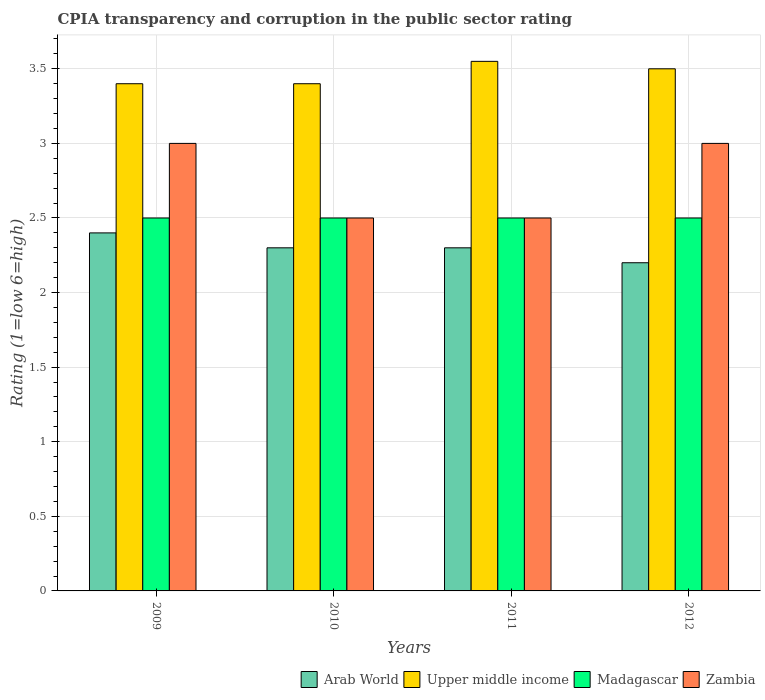How many different coloured bars are there?
Offer a very short reply. 4. How many bars are there on the 4th tick from the left?
Provide a succinct answer. 4. How many bars are there on the 2nd tick from the right?
Provide a short and direct response. 4. In how many cases, is the number of bars for a given year not equal to the number of legend labels?
Provide a succinct answer. 0. What is the CPIA rating in Arab World in 2011?
Provide a short and direct response. 2.3. In which year was the CPIA rating in Arab World minimum?
Give a very brief answer. 2012. What is the total CPIA rating in Upper middle income in the graph?
Your response must be concise. 13.85. What is the difference between the CPIA rating in Upper middle income in 2009 and that in 2011?
Ensure brevity in your answer.  -0.15. What is the difference between the CPIA rating in Arab World in 2011 and the CPIA rating in Madagascar in 2009?
Make the answer very short. -0.2. In the year 2009, what is the difference between the CPIA rating in Madagascar and CPIA rating in Upper middle income?
Give a very brief answer. -0.9. In how many years, is the CPIA rating in Madagascar greater than 2?
Make the answer very short. 4. What is the ratio of the CPIA rating in Arab World in 2010 to that in 2012?
Your response must be concise. 1.05. Is the CPIA rating in Upper middle income in 2009 less than that in 2012?
Your response must be concise. Yes. Is the difference between the CPIA rating in Madagascar in 2009 and 2012 greater than the difference between the CPIA rating in Upper middle income in 2009 and 2012?
Offer a very short reply. Yes. What is the difference between the highest and the second highest CPIA rating in Madagascar?
Give a very brief answer. 0. What is the difference between the highest and the lowest CPIA rating in Zambia?
Provide a succinct answer. 0.5. In how many years, is the CPIA rating in Madagascar greater than the average CPIA rating in Madagascar taken over all years?
Offer a very short reply. 0. Is it the case that in every year, the sum of the CPIA rating in Upper middle income and CPIA rating in Zambia is greater than the sum of CPIA rating in Arab World and CPIA rating in Madagascar?
Offer a terse response. No. What does the 3rd bar from the left in 2009 represents?
Offer a very short reply. Madagascar. What does the 2nd bar from the right in 2011 represents?
Your answer should be compact. Madagascar. How many bars are there?
Provide a succinct answer. 16. Are the values on the major ticks of Y-axis written in scientific E-notation?
Provide a short and direct response. No. Does the graph contain any zero values?
Make the answer very short. No. Does the graph contain grids?
Make the answer very short. Yes. How many legend labels are there?
Offer a terse response. 4. How are the legend labels stacked?
Make the answer very short. Horizontal. What is the title of the graph?
Provide a succinct answer. CPIA transparency and corruption in the public sector rating. What is the label or title of the X-axis?
Make the answer very short. Years. What is the Rating (1=low 6=high) in Arab World in 2009?
Your response must be concise. 2.4. What is the Rating (1=low 6=high) in Upper middle income in 2009?
Your answer should be very brief. 3.4. What is the Rating (1=low 6=high) of Zambia in 2009?
Provide a succinct answer. 3. What is the Rating (1=low 6=high) of Upper middle income in 2010?
Provide a short and direct response. 3.4. What is the Rating (1=low 6=high) in Madagascar in 2010?
Your answer should be compact. 2.5. What is the Rating (1=low 6=high) of Arab World in 2011?
Ensure brevity in your answer.  2.3. What is the Rating (1=low 6=high) in Upper middle income in 2011?
Offer a very short reply. 3.55. What is the Rating (1=low 6=high) in Arab World in 2012?
Ensure brevity in your answer.  2.2. What is the Rating (1=low 6=high) in Upper middle income in 2012?
Make the answer very short. 3.5. What is the Rating (1=low 6=high) in Madagascar in 2012?
Provide a short and direct response. 2.5. Across all years, what is the maximum Rating (1=low 6=high) in Upper middle income?
Offer a very short reply. 3.55. Across all years, what is the maximum Rating (1=low 6=high) of Zambia?
Your answer should be compact. 3. Across all years, what is the minimum Rating (1=low 6=high) in Upper middle income?
Offer a terse response. 3.4. Across all years, what is the minimum Rating (1=low 6=high) of Zambia?
Ensure brevity in your answer.  2.5. What is the total Rating (1=low 6=high) in Upper middle income in the graph?
Ensure brevity in your answer.  13.85. What is the total Rating (1=low 6=high) of Zambia in the graph?
Keep it short and to the point. 11. What is the difference between the Rating (1=low 6=high) of Arab World in 2009 and that in 2010?
Keep it short and to the point. 0.1. What is the difference between the Rating (1=low 6=high) in Madagascar in 2009 and that in 2010?
Your answer should be very brief. 0. What is the difference between the Rating (1=low 6=high) of Zambia in 2009 and that in 2010?
Provide a short and direct response. 0.5. What is the difference between the Rating (1=low 6=high) of Arab World in 2009 and that in 2011?
Provide a short and direct response. 0.1. What is the difference between the Rating (1=low 6=high) in Zambia in 2009 and that in 2011?
Offer a very short reply. 0.5. What is the difference between the Rating (1=low 6=high) in Madagascar in 2010 and that in 2011?
Provide a succinct answer. 0. What is the difference between the Rating (1=low 6=high) in Arab World in 2010 and that in 2012?
Offer a terse response. 0.1. What is the difference between the Rating (1=low 6=high) in Upper middle income in 2010 and that in 2012?
Provide a succinct answer. -0.1. What is the difference between the Rating (1=low 6=high) of Madagascar in 2010 and that in 2012?
Provide a short and direct response. 0. What is the difference between the Rating (1=low 6=high) in Upper middle income in 2011 and that in 2012?
Provide a short and direct response. 0.05. What is the difference between the Rating (1=low 6=high) in Arab World in 2009 and the Rating (1=low 6=high) in Madagascar in 2010?
Your answer should be very brief. -0.1. What is the difference between the Rating (1=low 6=high) in Arab World in 2009 and the Rating (1=low 6=high) in Zambia in 2010?
Provide a short and direct response. -0.1. What is the difference between the Rating (1=low 6=high) of Madagascar in 2009 and the Rating (1=low 6=high) of Zambia in 2010?
Provide a succinct answer. 0. What is the difference between the Rating (1=low 6=high) of Arab World in 2009 and the Rating (1=low 6=high) of Upper middle income in 2011?
Offer a terse response. -1.15. What is the difference between the Rating (1=low 6=high) of Madagascar in 2009 and the Rating (1=low 6=high) of Zambia in 2011?
Your response must be concise. 0. What is the difference between the Rating (1=low 6=high) in Arab World in 2009 and the Rating (1=low 6=high) in Upper middle income in 2012?
Your answer should be compact. -1.1. What is the difference between the Rating (1=low 6=high) of Arab World in 2009 and the Rating (1=low 6=high) of Madagascar in 2012?
Provide a succinct answer. -0.1. What is the difference between the Rating (1=low 6=high) of Upper middle income in 2009 and the Rating (1=low 6=high) of Zambia in 2012?
Keep it short and to the point. 0.4. What is the difference between the Rating (1=low 6=high) in Arab World in 2010 and the Rating (1=low 6=high) in Upper middle income in 2011?
Ensure brevity in your answer.  -1.25. What is the difference between the Rating (1=low 6=high) of Arab World in 2010 and the Rating (1=low 6=high) of Madagascar in 2011?
Ensure brevity in your answer.  -0.2. What is the difference between the Rating (1=low 6=high) in Upper middle income in 2010 and the Rating (1=low 6=high) in Madagascar in 2011?
Provide a succinct answer. 0.9. What is the difference between the Rating (1=low 6=high) in Arab World in 2010 and the Rating (1=low 6=high) in Zambia in 2012?
Provide a succinct answer. -0.7. What is the difference between the Rating (1=low 6=high) in Upper middle income in 2010 and the Rating (1=low 6=high) in Madagascar in 2012?
Your response must be concise. 0.9. What is the difference between the Rating (1=low 6=high) of Arab World in 2011 and the Rating (1=low 6=high) of Upper middle income in 2012?
Ensure brevity in your answer.  -1.2. What is the difference between the Rating (1=low 6=high) of Arab World in 2011 and the Rating (1=low 6=high) of Zambia in 2012?
Your answer should be compact. -0.7. What is the difference between the Rating (1=low 6=high) in Upper middle income in 2011 and the Rating (1=low 6=high) in Zambia in 2012?
Provide a short and direct response. 0.55. What is the difference between the Rating (1=low 6=high) of Madagascar in 2011 and the Rating (1=low 6=high) of Zambia in 2012?
Ensure brevity in your answer.  -0.5. What is the average Rating (1=low 6=high) of Arab World per year?
Provide a short and direct response. 2.3. What is the average Rating (1=low 6=high) in Upper middle income per year?
Provide a short and direct response. 3.46. What is the average Rating (1=low 6=high) of Zambia per year?
Provide a short and direct response. 2.75. In the year 2009, what is the difference between the Rating (1=low 6=high) of Arab World and Rating (1=low 6=high) of Upper middle income?
Offer a very short reply. -1. In the year 2009, what is the difference between the Rating (1=low 6=high) of Arab World and Rating (1=low 6=high) of Madagascar?
Offer a terse response. -0.1. In the year 2009, what is the difference between the Rating (1=low 6=high) of Madagascar and Rating (1=low 6=high) of Zambia?
Provide a short and direct response. -0.5. In the year 2010, what is the difference between the Rating (1=low 6=high) in Arab World and Rating (1=low 6=high) in Upper middle income?
Offer a terse response. -1.1. In the year 2010, what is the difference between the Rating (1=low 6=high) of Arab World and Rating (1=low 6=high) of Madagascar?
Give a very brief answer. -0.2. In the year 2010, what is the difference between the Rating (1=low 6=high) of Arab World and Rating (1=low 6=high) of Zambia?
Keep it short and to the point. -0.2. In the year 2010, what is the difference between the Rating (1=low 6=high) of Upper middle income and Rating (1=low 6=high) of Madagascar?
Your answer should be very brief. 0.9. In the year 2010, what is the difference between the Rating (1=low 6=high) of Madagascar and Rating (1=low 6=high) of Zambia?
Your answer should be very brief. 0. In the year 2011, what is the difference between the Rating (1=low 6=high) in Arab World and Rating (1=low 6=high) in Upper middle income?
Make the answer very short. -1.25. In the year 2011, what is the difference between the Rating (1=low 6=high) in Arab World and Rating (1=low 6=high) in Madagascar?
Make the answer very short. -0.2. In the year 2011, what is the difference between the Rating (1=low 6=high) of Arab World and Rating (1=low 6=high) of Zambia?
Offer a terse response. -0.2. In the year 2011, what is the difference between the Rating (1=low 6=high) in Upper middle income and Rating (1=low 6=high) in Madagascar?
Your response must be concise. 1.05. In the year 2011, what is the difference between the Rating (1=low 6=high) in Upper middle income and Rating (1=low 6=high) in Zambia?
Offer a terse response. 1.05. In the year 2011, what is the difference between the Rating (1=low 6=high) in Madagascar and Rating (1=low 6=high) in Zambia?
Offer a terse response. 0. In the year 2012, what is the difference between the Rating (1=low 6=high) of Arab World and Rating (1=low 6=high) of Madagascar?
Keep it short and to the point. -0.3. In the year 2012, what is the difference between the Rating (1=low 6=high) in Upper middle income and Rating (1=low 6=high) in Madagascar?
Offer a terse response. 1. In the year 2012, what is the difference between the Rating (1=low 6=high) in Madagascar and Rating (1=low 6=high) in Zambia?
Your answer should be compact. -0.5. What is the ratio of the Rating (1=low 6=high) of Arab World in 2009 to that in 2010?
Provide a succinct answer. 1.04. What is the ratio of the Rating (1=low 6=high) in Madagascar in 2009 to that in 2010?
Keep it short and to the point. 1. What is the ratio of the Rating (1=low 6=high) in Arab World in 2009 to that in 2011?
Give a very brief answer. 1.04. What is the ratio of the Rating (1=low 6=high) in Upper middle income in 2009 to that in 2011?
Provide a short and direct response. 0.96. What is the ratio of the Rating (1=low 6=high) in Madagascar in 2009 to that in 2011?
Your answer should be very brief. 1. What is the ratio of the Rating (1=low 6=high) of Arab World in 2009 to that in 2012?
Keep it short and to the point. 1.09. What is the ratio of the Rating (1=low 6=high) in Upper middle income in 2009 to that in 2012?
Offer a terse response. 0.97. What is the ratio of the Rating (1=low 6=high) of Upper middle income in 2010 to that in 2011?
Provide a succinct answer. 0.96. What is the ratio of the Rating (1=low 6=high) of Arab World in 2010 to that in 2012?
Give a very brief answer. 1.05. What is the ratio of the Rating (1=low 6=high) of Upper middle income in 2010 to that in 2012?
Offer a very short reply. 0.97. What is the ratio of the Rating (1=low 6=high) of Madagascar in 2010 to that in 2012?
Your answer should be compact. 1. What is the ratio of the Rating (1=low 6=high) of Zambia in 2010 to that in 2012?
Make the answer very short. 0.83. What is the ratio of the Rating (1=low 6=high) of Arab World in 2011 to that in 2012?
Your response must be concise. 1.05. What is the ratio of the Rating (1=low 6=high) of Upper middle income in 2011 to that in 2012?
Make the answer very short. 1.01. What is the ratio of the Rating (1=low 6=high) of Madagascar in 2011 to that in 2012?
Provide a short and direct response. 1. What is the ratio of the Rating (1=low 6=high) of Zambia in 2011 to that in 2012?
Your answer should be compact. 0.83. What is the difference between the highest and the second highest Rating (1=low 6=high) of Arab World?
Give a very brief answer. 0.1. What is the difference between the highest and the second highest Rating (1=low 6=high) in Upper middle income?
Provide a short and direct response. 0.05. What is the difference between the highest and the lowest Rating (1=low 6=high) in Upper middle income?
Your answer should be compact. 0.15. What is the difference between the highest and the lowest Rating (1=low 6=high) of Zambia?
Give a very brief answer. 0.5. 